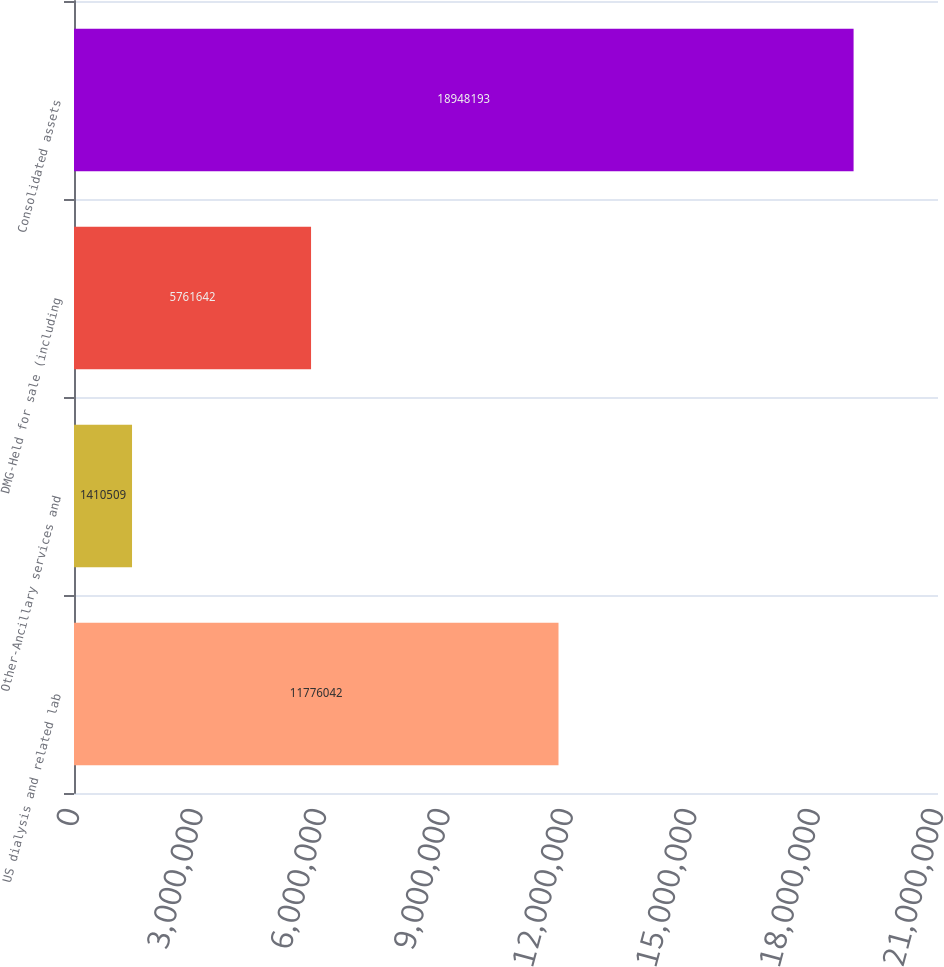<chart> <loc_0><loc_0><loc_500><loc_500><bar_chart><fcel>US dialysis and related lab<fcel>Other-Ancillary services and<fcel>DMG-Held for sale (including<fcel>Consolidated assets<nl><fcel>1.1776e+07<fcel>1.41051e+06<fcel>5.76164e+06<fcel>1.89482e+07<nl></chart> 